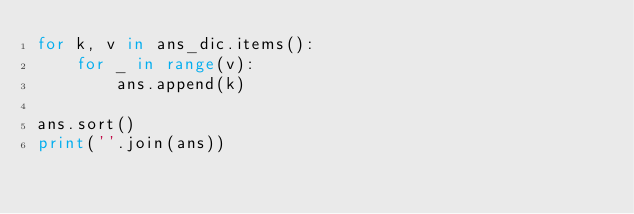<code> <loc_0><loc_0><loc_500><loc_500><_Python_>for k, v in ans_dic.items():
    for _ in range(v):
        ans.append(k)

ans.sort()
print(''.join(ans))
</code> 